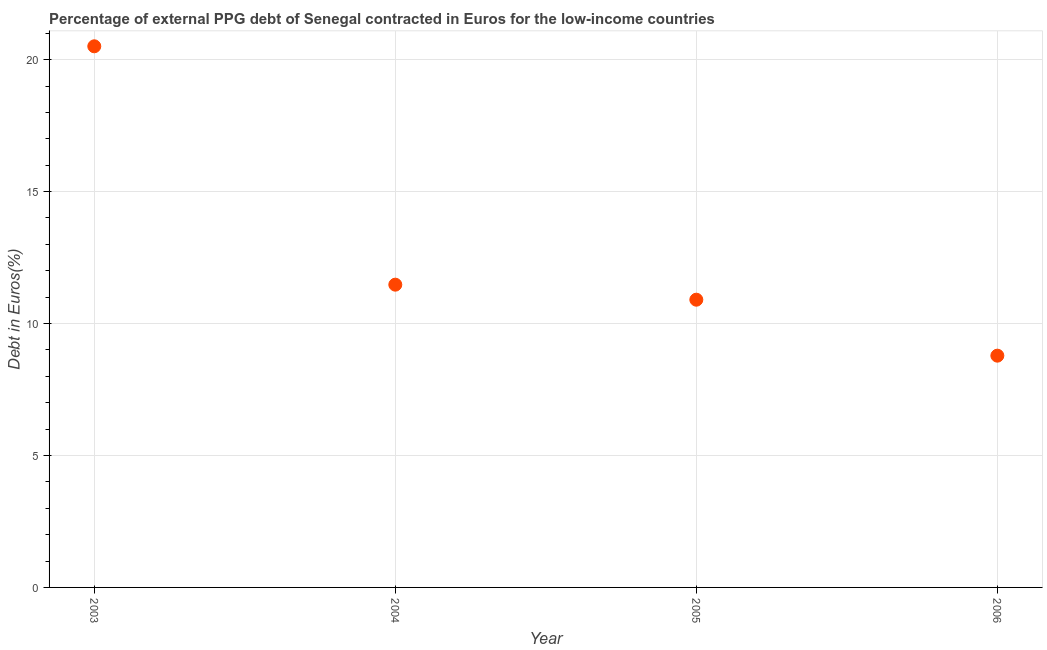What is the currency composition of ppg debt in 2006?
Provide a short and direct response. 8.78. Across all years, what is the maximum currency composition of ppg debt?
Your response must be concise. 20.51. Across all years, what is the minimum currency composition of ppg debt?
Ensure brevity in your answer.  8.78. In which year was the currency composition of ppg debt maximum?
Keep it short and to the point. 2003. What is the sum of the currency composition of ppg debt?
Give a very brief answer. 51.67. What is the difference between the currency composition of ppg debt in 2003 and 2005?
Your answer should be compact. 9.6. What is the average currency composition of ppg debt per year?
Make the answer very short. 12.92. What is the median currency composition of ppg debt?
Offer a terse response. 11.19. What is the ratio of the currency composition of ppg debt in 2004 to that in 2006?
Provide a short and direct response. 1.31. What is the difference between the highest and the second highest currency composition of ppg debt?
Keep it short and to the point. 9.03. Is the sum of the currency composition of ppg debt in 2003 and 2004 greater than the maximum currency composition of ppg debt across all years?
Make the answer very short. Yes. What is the difference between the highest and the lowest currency composition of ppg debt?
Keep it short and to the point. 11.72. In how many years, is the currency composition of ppg debt greater than the average currency composition of ppg debt taken over all years?
Your response must be concise. 1. How many dotlines are there?
Give a very brief answer. 1. How many years are there in the graph?
Your response must be concise. 4. What is the title of the graph?
Offer a terse response. Percentage of external PPG debt of Senegal contracted in Euros for the low-income countries. What is the label or title of the Y-axis?
Make the answer very short. Debt in Euros(%). What is the Debt in Euros(%) in 2003?
Ensure brevity in your answer.  20.51. What is the Debt in Euros(%) in 2004?
Your response must be concise. 11.47. What is the Debt in Euros(%) in 2005?
Offer a very short reply. 10.9. What is the Debt in Euros(%) in 2006?
Your response must be concise. 8.78. What is the difference between the Debt in Euros(%) in 2003 and 2004?
Make the answer very short. 9.03. What is the difference between the Debt in Euros(%) in 2003 and 2005?
Your response must be concise. 9.6. What is the difference between the Debt in Euros(%) in 2003 and 2006?
Ensure brevity in your answer.  11.72. What is the difference between the Debt in Euros(%) in 2004 and 2005?
Keep it short and to the point. 0.57. What is the difference between the Debt in Euros(%) in 2004 and 2006?
Your answer should be very brief. 2.69. What is the difference between the Debt in Euros(%) in 2005 and 2006?
Your response must be concise. 2.12. What is the ratio of the Debt in Euros(%) in 2003 to that in 2004?
Your answer should be compact. 1.79. What is the ratio of the Debt in Euros(%) in 2003 to that in 2005?
Ensure brevity in your answer.  1.88. What is the ratio of the Debt in Euros(%) in 2003 to that in 2006?
Make the answer very short. 2.33. What is the ratio of the Debt in Euros(%) in 2004 to that in 2005?
Give a very brief answer. 1.05. What is the ratio of the Debt in Euros(%) in 2004 to that in 2006?
Make the answer very short. 1.31. What is the ratio of the Debt in Euros(%) in 2005 to that in 2006?
Make the answer very short. 1.24. 